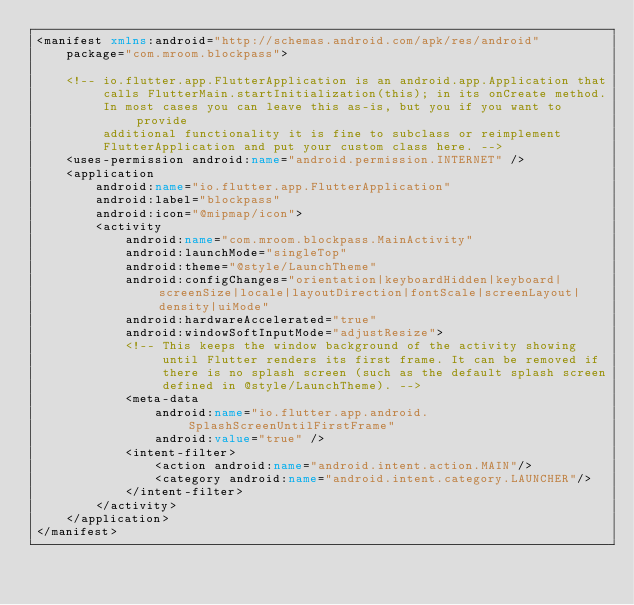Convert code to text. <code><loc_0><loc_0><loc_500><loc_500><_XML_><manifest xmlns:android="http://schemas.android.com/apk/res/android"
    package="com.mroom.blockpass">

    <!-- io.flutter.app.FlutterApplication is an android.app.Application that
         calls FlutterMain.startInitialization(this); in its onCreate method.
         In most cases you can leave this as-is, but you if you want to provide
         additional functionality it is fine to subclass or reimplement
         FlutterApplication and put your custom class here. -->
    <uses-permission android:name="android.permission.INTERNET" />
    <application
        android:name="io.flutter.app.FlutterApplication"
        android:label="blockpass"
        android:icon="@mipmap/icon">
        <activity
            android:name="com.mroom.blockpass.MainActivity"
            android:launchMode="singleTop"
            android:theme="@style/LaunchTheme"
            android:configChanges="orientation|keyboardHidden|keyboard|screenSize|locale|layoutDirection|fontScale|screenLayout|density|uiMode"
            android:hardwareAccelerated="true"
            android:windowSoftInputMode="adjustResize">
            <!-- This keeps the window background of the activity showing
                 until Flutter renders its first frame. It can be removed if
                 there is no splash screen (such as the default splash screen
                 defined in @style/LaunchTheme). -->
            <meta-data
                android:name="io.flutter.app.android.SplashScreenUntilFirstFrame"
                android:value="true" />
            <intent-filter>
                <action android:name="android.intent.action.MAIN"/>
                <category android:name="android.intent.category.LAUNCHER"/>
            </intent-filter>
        </activity>
    </application>
</manifest>
</code> 